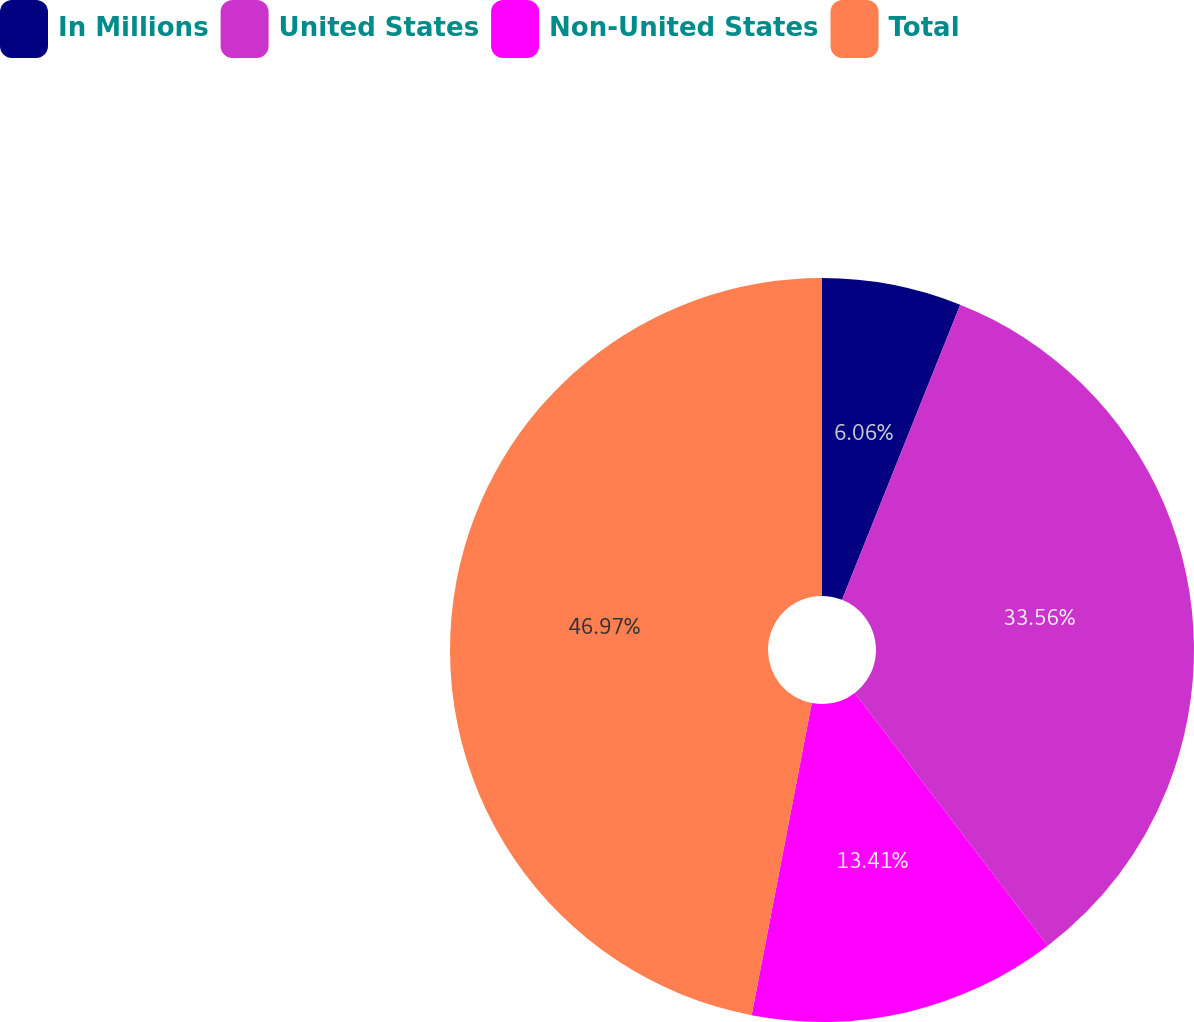Convert chart. <chart><loc_0><loc_0><loc_500><loc_500><pie_chart><fcel>In Millions<fcel>United States<fcel>Non-United States<fcel>Total<nl><fcel>6.06%<fcel>33.56%<fcel>13.41%<fcel>46.97%<nl></chart> 